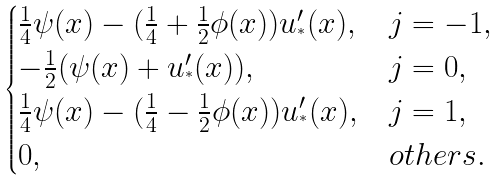<formula> <loc_0><loc_0><loc_500><loc_500>\begin{cases} \frac { 1 } { 4 } \psi ( x ) - ( \frac { 1 } { 4 } + \frac { 1 } { 2 } \phi ( x ) ) u _ { ^ { * } } ^ { \prime } ( x ) , & j = - 1 , \\ - \frac { 1 } { 2 } ( \psi ( x ) + u _ { ^ { * } } ^ { \prime } ( x ) ) , & j = 0 , \\ \frac { 1 } { 4 } \psi ( x ) - ( \frac { 1 } { 4 } - \frac { 1 } { 2 } \phi ( x ) ) u _ { ^ { * } } ^ { \prime } ( x ) , & j = 1 , \\ 0 , & o t h e r s . \end{cases}</formula> 